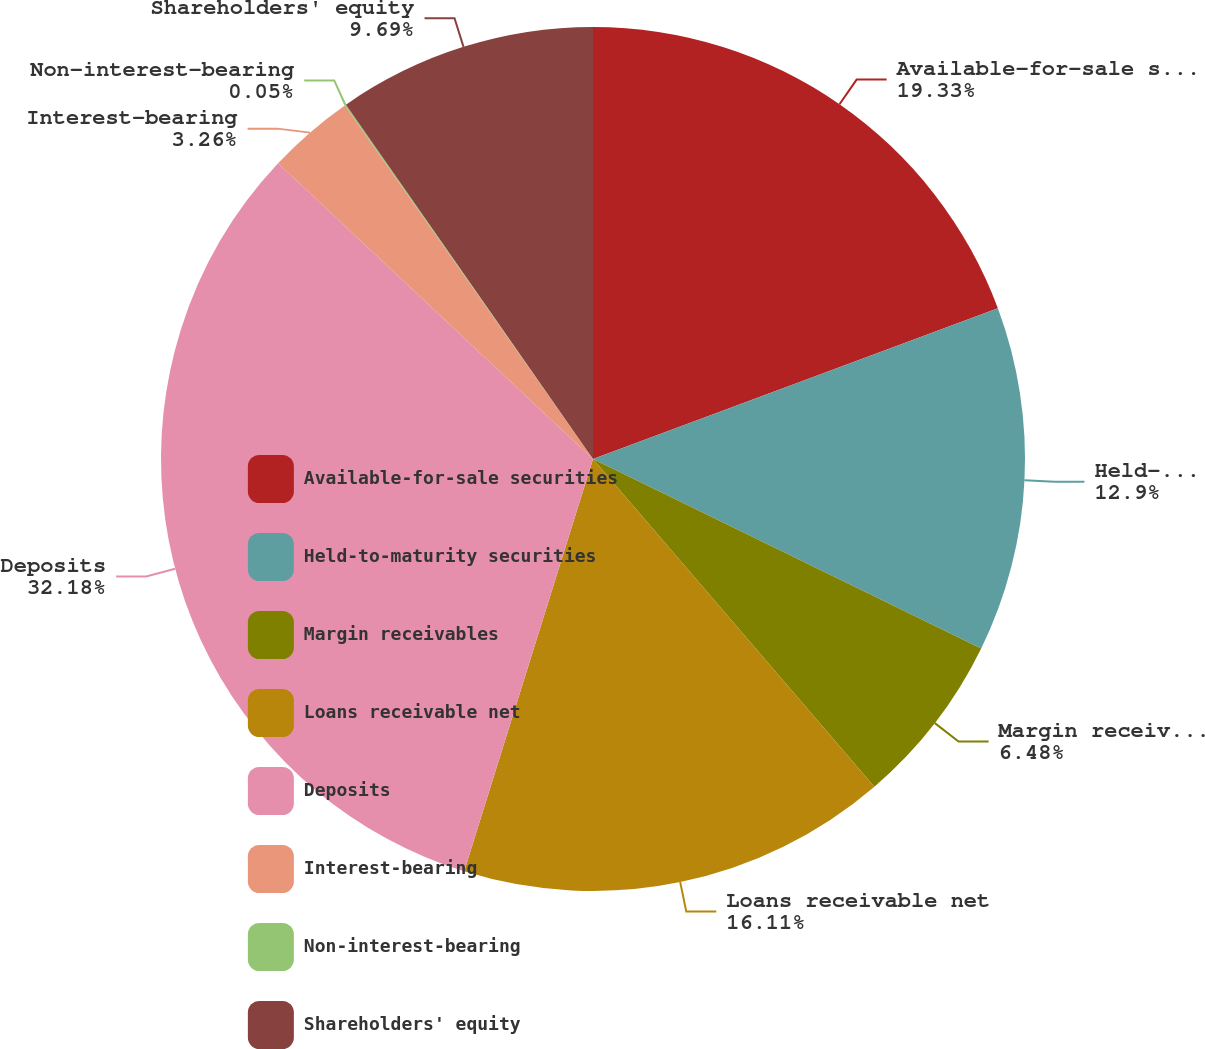<chart> <loc_0><loc_0><loc_500><loc_500><pie_chart><fcel>Available-for-sale securities<fcel>Held-to-maturity securities<fcel>Margin receivables<fcel>Loans receivable net<fcel>Deposits<fcel>Interest-bearing<fcel>Non-interest-bearing<fcel>Shareholders' equity<nl><fcel>19.33%<fcel>12.9%<fcel>6.48%<fcel>16.11%<fcel>32.18%<fcel>3.26%<fcel>0.05%<fcel>9.69%<nl></chart> 